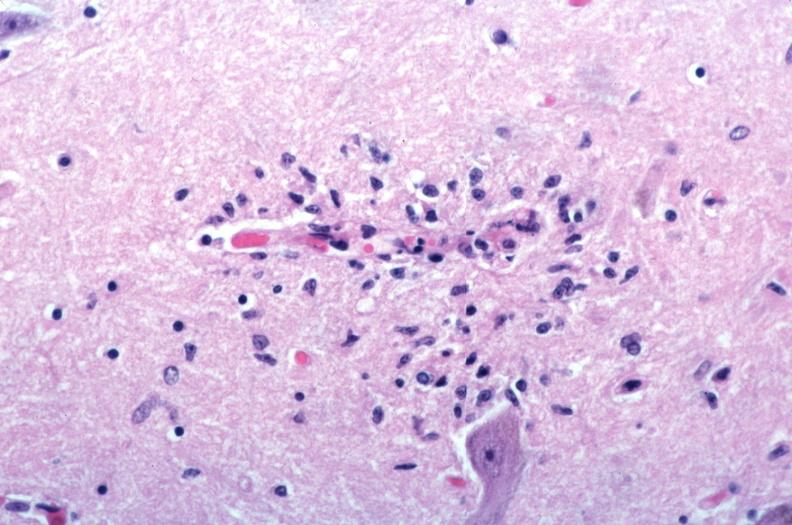where is this?
Answer the question using a single word or phrase. Nervous 